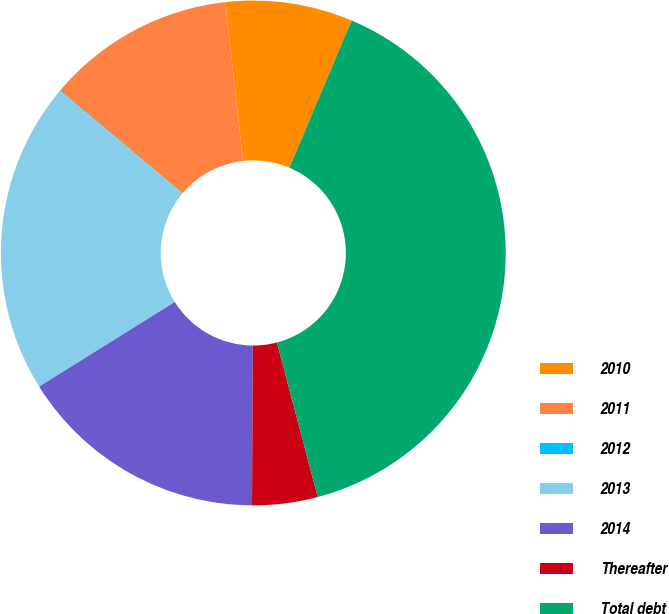Convert chart to OTSL. <chart><loc_0><loc_0><loc_500><loc_500><pie_chart><fcel>2010<fcel>2011<fcel>2012<fcel>2013<fcel>2014<fcel>Thereafter<fcel>Total debt<nl><fcel>8.14%<fcel>12.09%<fcel>0.04%<fcel>19.98%<fcel>16.04%<fcel>4.19%<fcel>39.52%<nl></chart> 